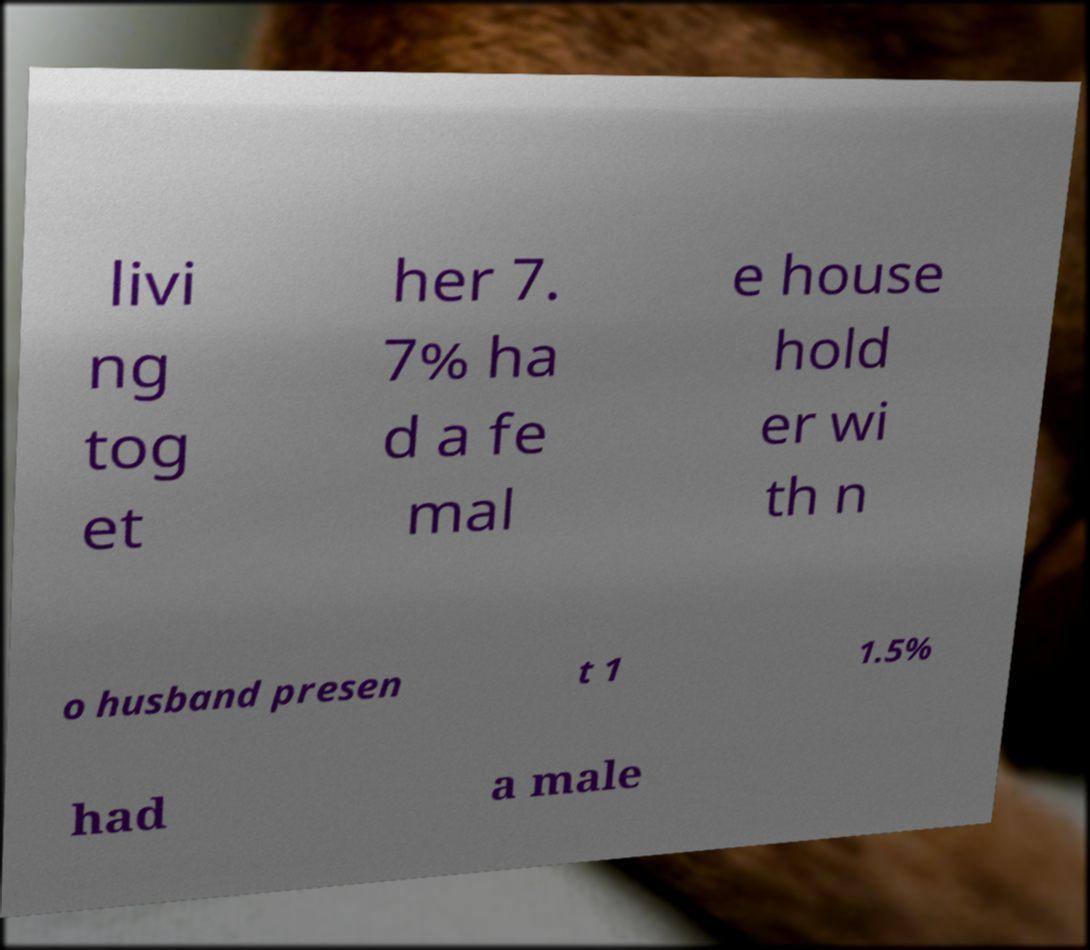For documentation purposes, I need the text within this image transcribed. Could you provide that? livi ng tog et her 7. 7% ha d a fe mal e house hold er wi th n o husband presen t 1 1.5% had a male 